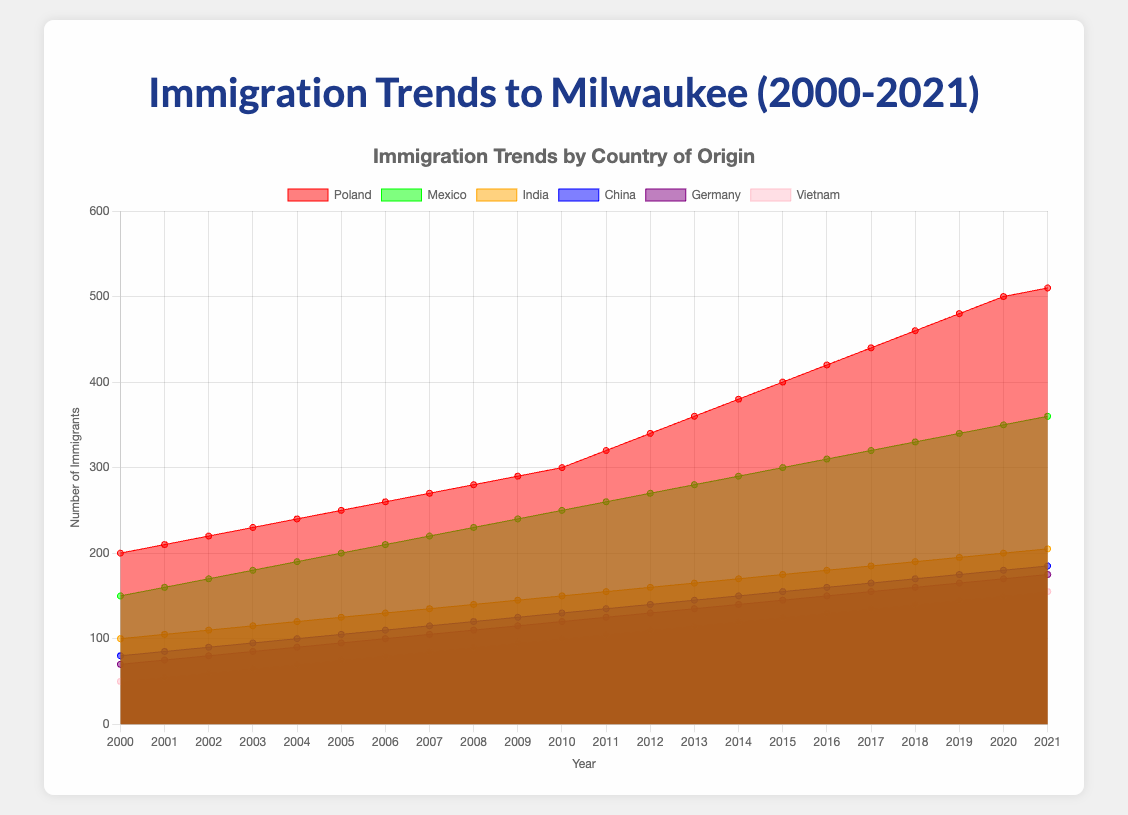What's the title of the chart? The title is clearly displayed at the top of the figure, above the chart. It reads "Immigration Trends by Country of Origin."
Answer: Immigration Trends by Country of Origin Which country has the highest number of immigrants to Milwaukee in 2021? By looking at the chart, you can identify that the area corresponding to Poland is the largest in 2021, indicating the highest number of immigrants.
Answer: Poland How did the number of Polish immigrants change from 2000 to 2021? Observing the red area for Poland, you can see that the number of immigrants increased steadily over the years from 200 in 2000 to 510 in 2021.
Answer: Increased What is the combined number of immigrants from India and China in 2015? First, find the values for India and China in 2015 (India: 175, China: 155). Add these values together (175 + 155 = 330).
Answer: 330 Which country showed the most consistent rate of increase in immigration over the years? Reviewing the areas, Poland demonstrates a steady and consistent increase each year without any declines or stagnations, indicating the most consistent rate of increase.
Answer: Poland What trend can be observed for Vietnamese immigrants from 2000 to 2021? The pink area representing Vietnam shows a steady increase in the number of immigrants from 50 in 2000 to 155 in 2021.
Answer: Steady increase Compare the growth of immigrants from Mexico and Germany between 2010 and 2015. Which country had a higher growth rate? Calculate the difference between 2010 and 2015 for both: (Mexico: 300 - 250 = 50), (Germany: 145 - 120 = 25). Mexico's increase of 50 is higher than Germany's increase of 25.
Answer: Mexico What is the approximate number of immigrants from Vietnam and Germany combined in 2010? Identify the numbers for each country in 2010 (Vietnam: 100, Germany: 120) and add them together (100 + 120 = 220).
Answer: 220 How did the number of Chinese immigrants change between 2005 and 2015? Subtract the number in 2005 (105) from the number in 2015 (155) to find the change (155 - 105 = 50).
Answer: Increased by 50 